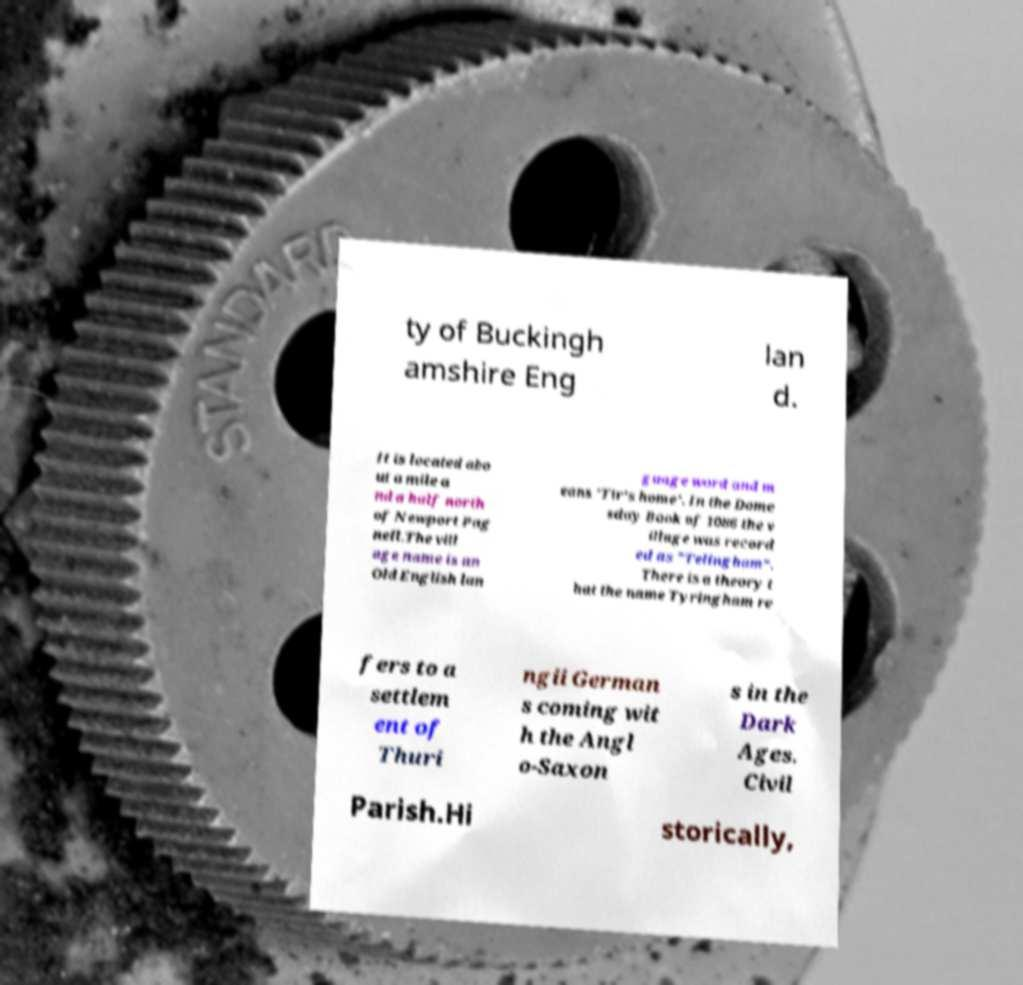There's text embedded in this image that I need extracted. Can you transcribe it verbatim? ty of Buckingh amshire Eng lan d. It is located abo ut a mile a nd a half north of Newport Pag nell.The vill age name is an Old English lan guage word and m eans 'Tir's home'. In the Dome sday Book of 1086 the v illage was record ed as "Telingham". There is a theory t hat the name Tyringham re fers to a settlem ent of Thuri ngii German s coming wit h the Angl o-Saxon s in the Dark Ages. Civil Parish.Hi storically, 